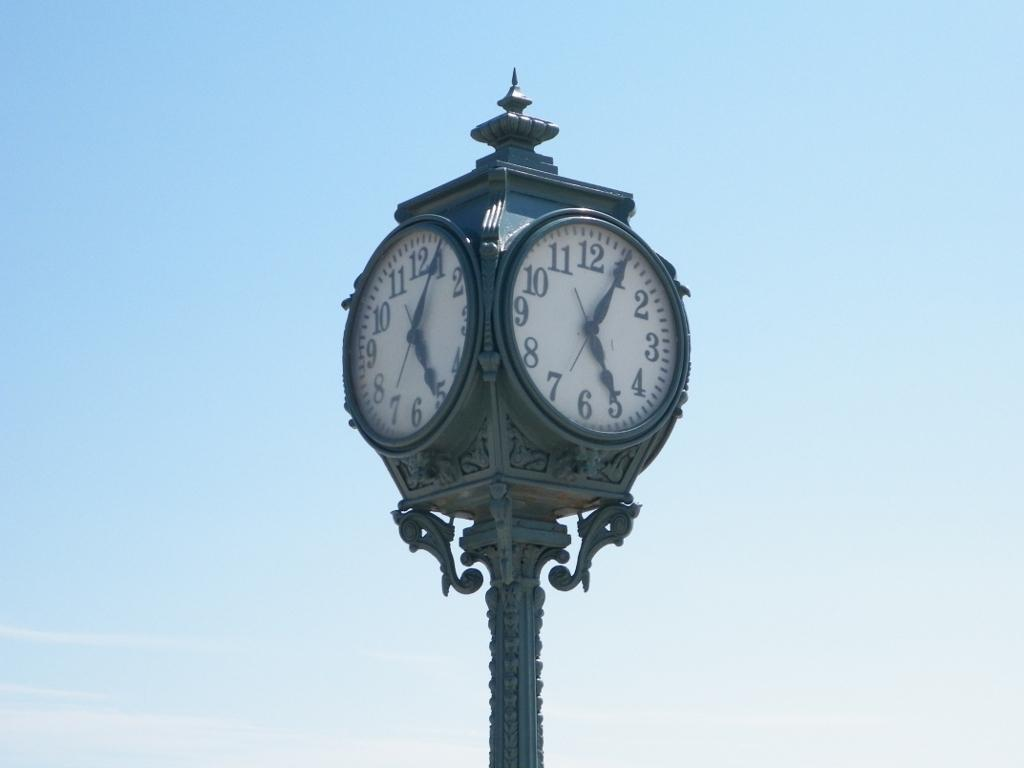<image>
Give a short and clear explanation of the subsequent image. Tall clock with the hands at 1 and 5. 